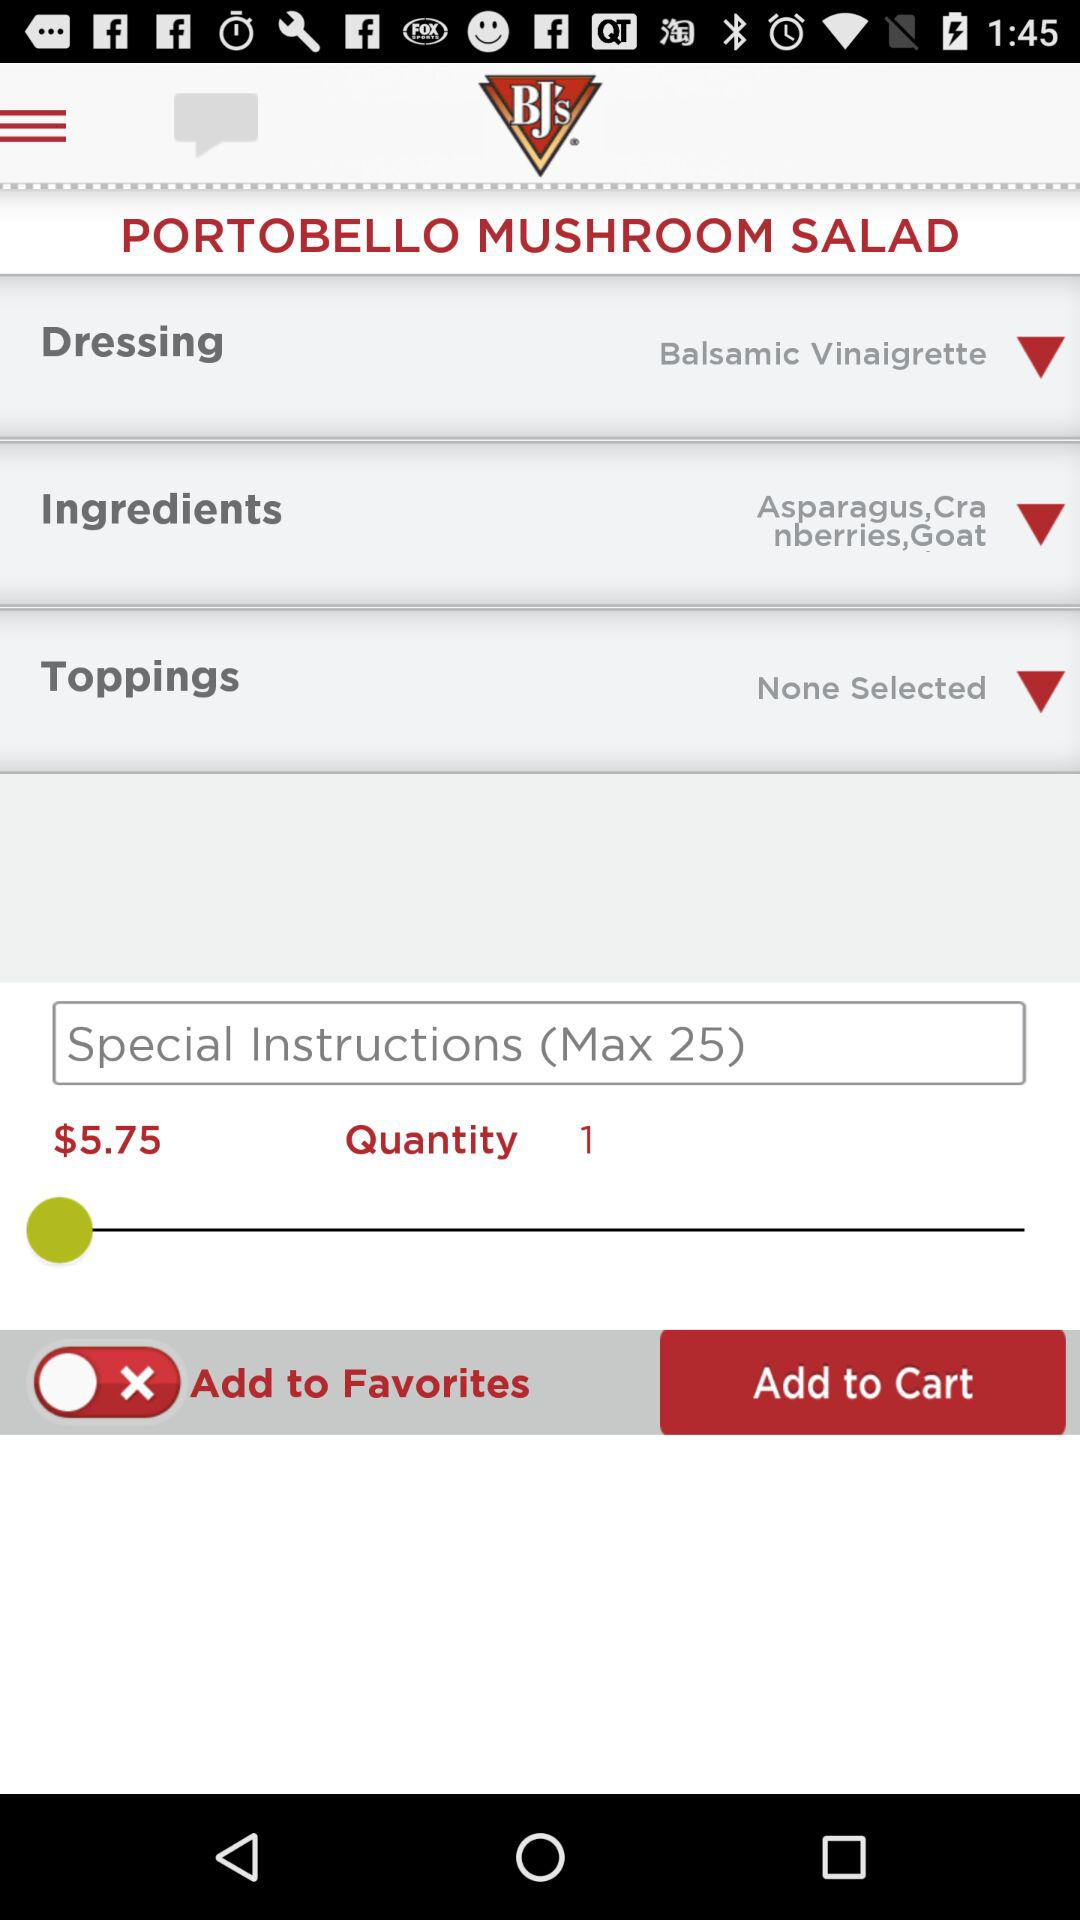Which type of dressing is used? The type of dressing is balsamic vinaigrette. 